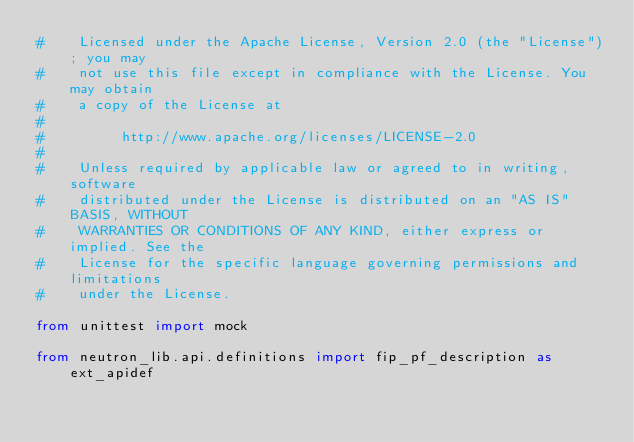<code> <loc_0><loc_0><loc_500><loc_500><_Python_>#    Licensed under the Apache License, Version 2.0 (the "License"); you may
#    not use this file except in compliance with the License. You may obtain
#    a copy of the License at
#
#         http://www.apache.org/licenses/LICENSE-2.0
#
#    Unless required by applicable law or agreed to in writing, software
#    distributed under the License is distributed on an "AS IS" BASIS, WITHOUT
#    WARRANTIES OR CONDITIONS OF ANY KIND, either express or implied. See the
#    License for the specific language governing permissions and limitations
#    under the License.

from unittest import mock

from neutron_lib.api.definitions import fip_pf_description as ext_apidef</code> 